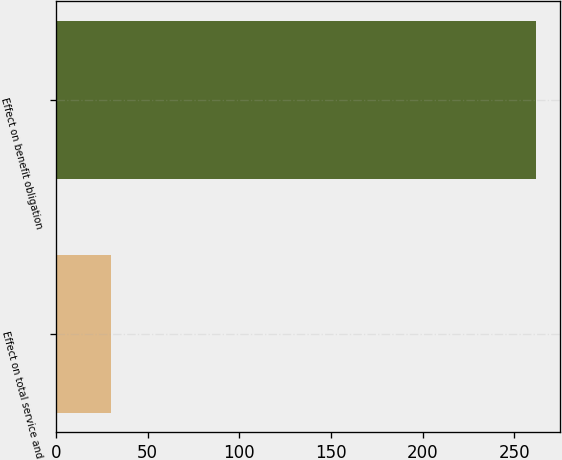<chart> <loc_0><loc_0><loc_500><loc_500><bar_chart><fcel>Effect on total service and<fcel>Effect on benefit obligation<nl><fcel>30<fcel>262<nl></chart> 